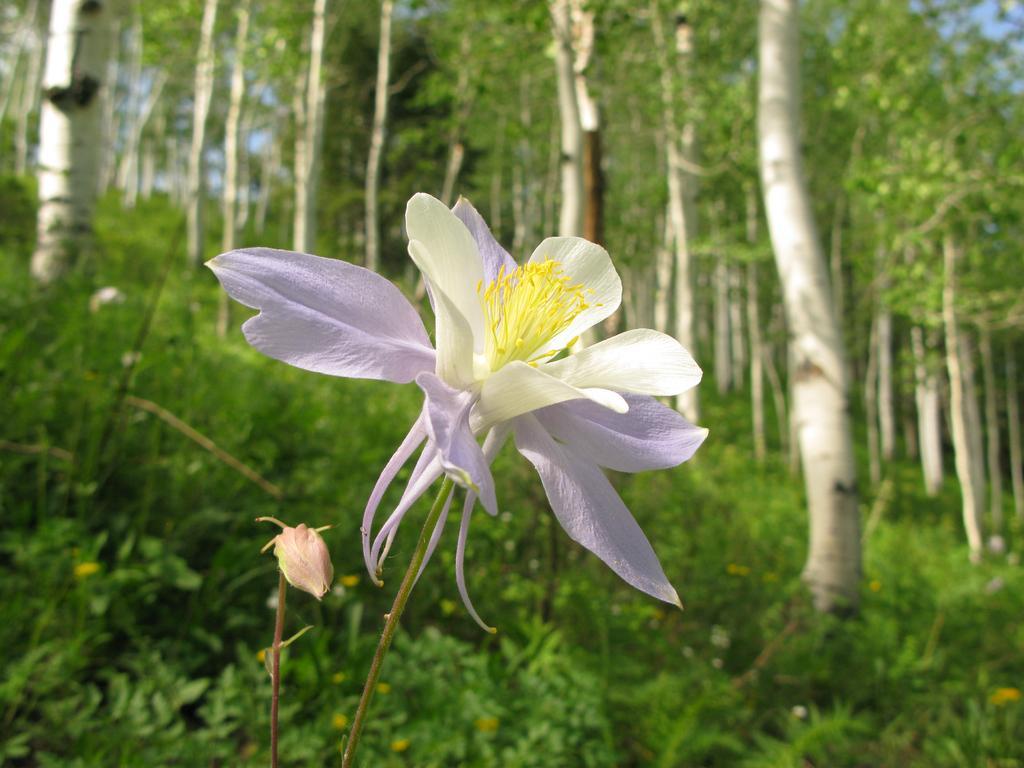Can you describe this image briefly? In the center of the image, we can see a flower and a bud. In the background, there are trees. 